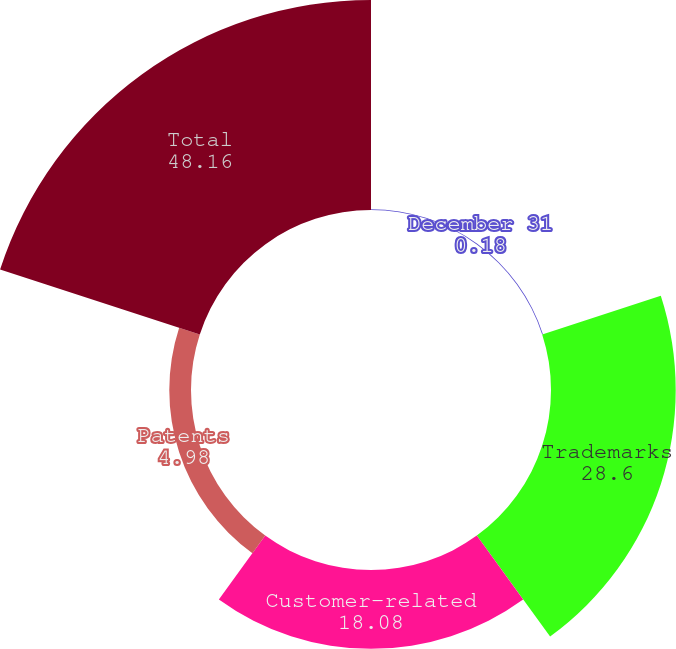<chart> <loc_0><loc_0><loc_500><loc_500><pie_chart><fcel>December 31<fcel>Trademarks<fcel>Customer-related<fcel>Patents<fcel>Total<nl><fcel>0.18%<fcel>28.6%<fcel>18.08%<fcel>4.98%<fcel>48.16%<nl></chart> 